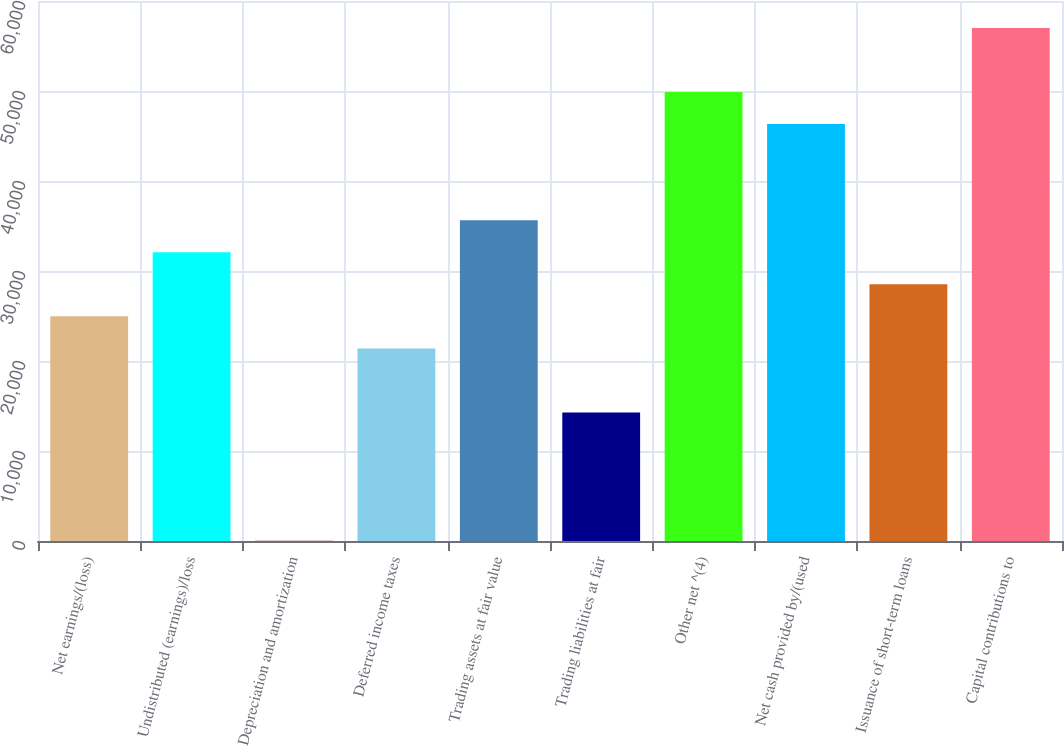Convert chart to OTSL. <chart><loc_0><loc_0><loc_500><loc_500><bar_chart><fcel>Net earnings/(loss)<fcel>Undistributed (earnings)/loss<fcel>Depreciation and amortization<fcel>Deferred income taxes<fcel>Trading assets at fair value<fcel>Trading liabilities at fair<fcel>Other net ^(4)<fcel>Net cash provided by/(used<fcel>Issuance of short-term loans<fcel>Capital contributions to<nl><fcel>24962.3<fcel>32084.1<fcel>36<fcel>21401.4<fcel>35645<fcel>14279.6<fcel>49888.6<fcel>46327.7<fcel>28523.2<fcel>57010.4<nl></chart> 